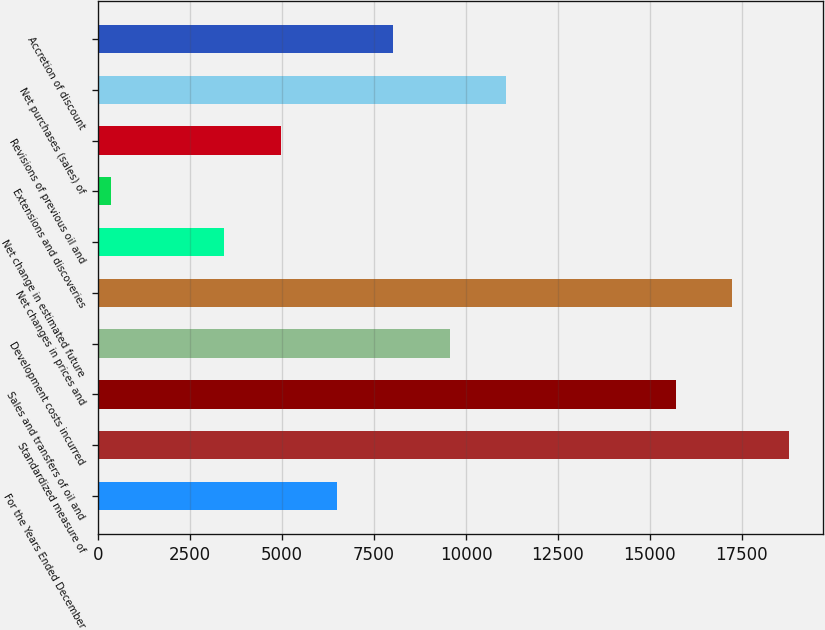Convert chart. <chart><loc_0><loc_0><loc_500><loc_500><bar_chart><fcel>For the Years Ended December<fcel>Standardized measure of<fcel>Sales and transfers of oil and<fcel>Development costs incurred<fcel>Net changes in prices and<fcel>Net change in estimated future<fcel>Extensions and discoveries<fcel>Revisions of previous oil and<fcel>Net purchases (sales) of<fcel>Accretion of discount<nl><fcel>6494.4<fcel>18771.2<fcel>15702<fcel>9563.6<fcel>17236.6<fcel>3425.2<fcel>356<fcel>4959.8<fcel>11098.2<fcel>8029<nl></chart> 